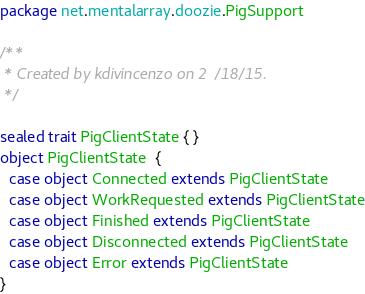<code> <loc_0><loc_0><loc_500><loc_500><_Scala_>package net.mentalarray.doozie.PigSupport

/**
 * Created by kdivincenzo on 2/18/15.
 */

sealed trait PigClientState { }
object PigClientState  {
  case object Connected extends PigClientState
  case object WorkRequested extends PigClientState
  case object Finished extends PigClientState
  case object Disconnected extends PigClientState
  case object Error extends PigClientState
}
</code> 